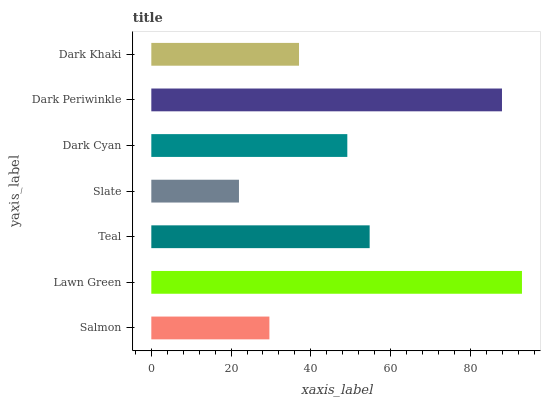Is Slate the minimum?
Answer yes or no. Yes. Is Lawn Green the maximum?
Answer yes or no. Yes. Is Teal the minimum?
Answer yes or no. No. Is Teal the maximum?
Answer yes or no. No. Is Lawn Green greater than Teal?
Answer yes or no. Yes. Is Teal less than Lawn Green?
Answer yes or no. Yes. Is Teal greater than Lawn Green?
Answer yes or no. No. Is Lawn Green less than Teal?
Answer yes or no. No. Is Dark Cyan the high median?
Answer yes or no. Yes. Is Dark Cyan the low median?
Answer yes or no. Yes. Is Slate the high median?
Answer yes or no. No. Is Teal the low median?
Answer yes or no. No. 